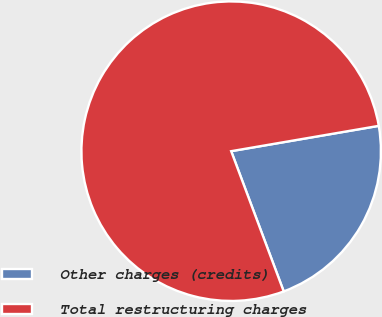Convert chart. <chart><loc_0><loc_0><loc_500><loc_500><pie_chart><fcel>Other charges (credits)<fcel>Total restructuring charges<nl><fcel>22.0%<fcel>78.0%<nl></chart> 